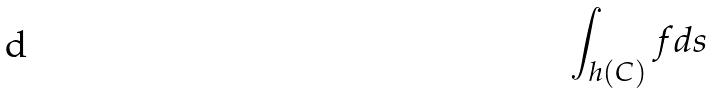<formula> <loc_0><loc_0><loc_500><loc_500>\int _ { h ( C ) } f d s</formula> 